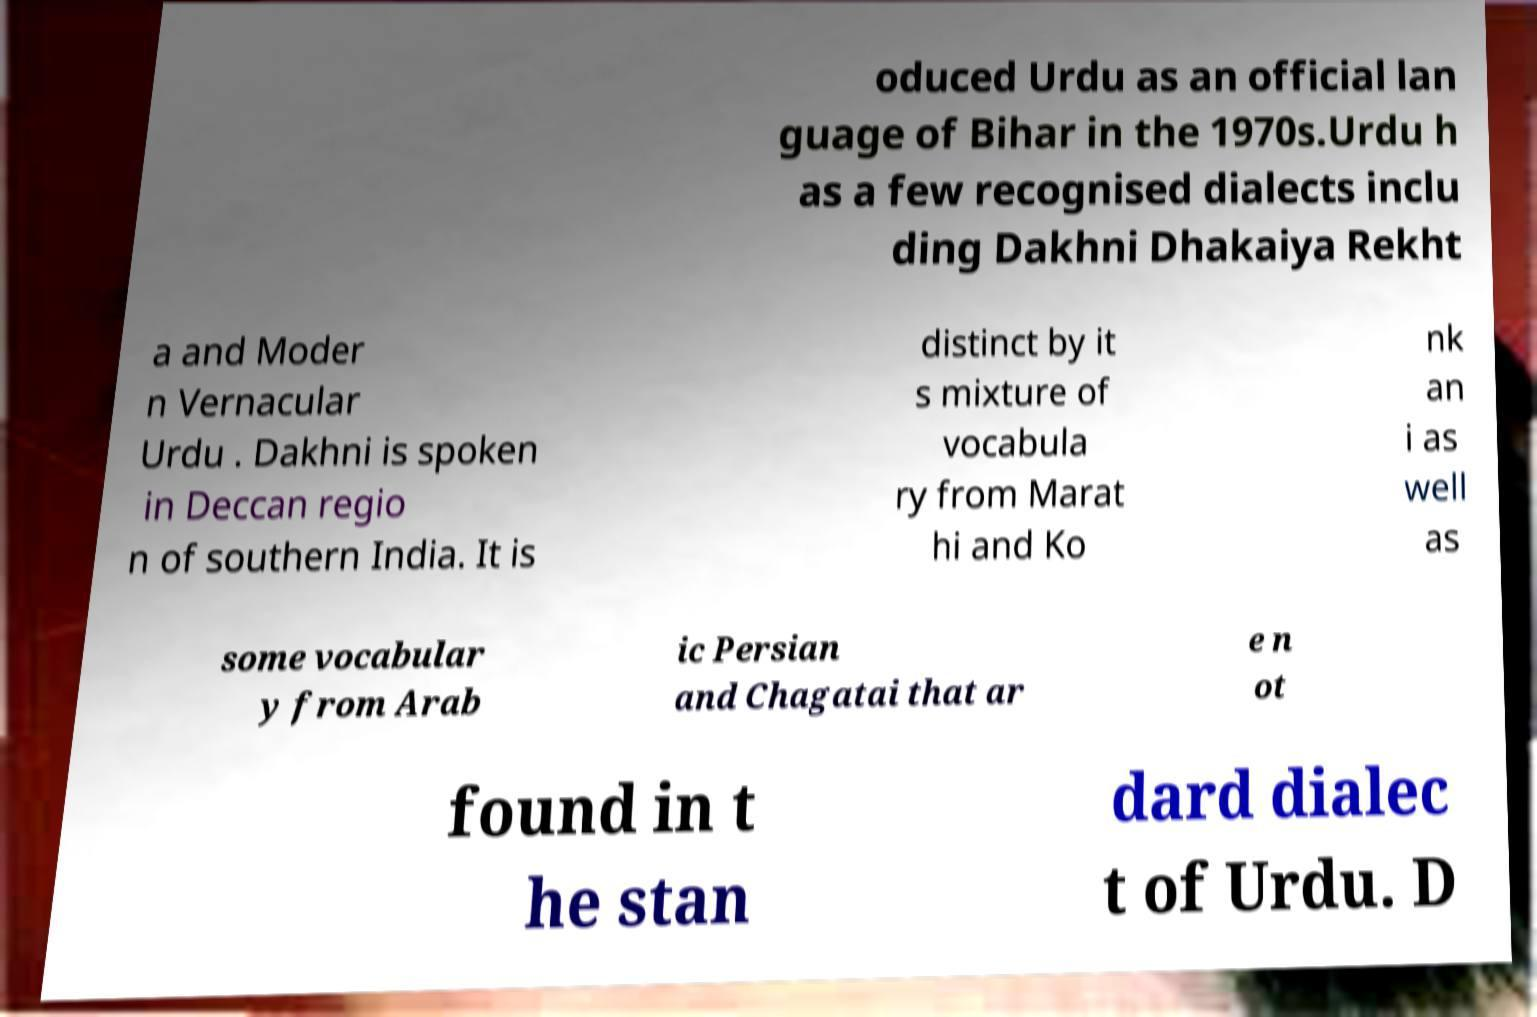What messages or text are displayed in this image? I need them in a readable, typed format. oduced Urdu as an official lan guage of Bihar in the 1970s.Urdu h as a few recognised dialects inclu ding Dakhni Dhakaiya Rekht a and Moder n Vernacular Urdu . Dakhni is spoken in Deccan regio n of southern India. It is distinct by it s mixture of vocabula ry from Marat hi and Ko nk an i as well as some vocabular y from Arab ic Persian and Chagatai that ar e n ot found in t he stan dard dialec t of Urdu. D 